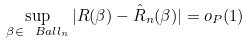Convert formula to latex. <formula><loc_0><loc_0><loc_500><loc_500>\sup _ { \beta \in \ B a l l _ { n } } | R ( \beta ) - \hat { R } _ { n } ( \beta ) | = o _ { P } ( 1 )</formula> 